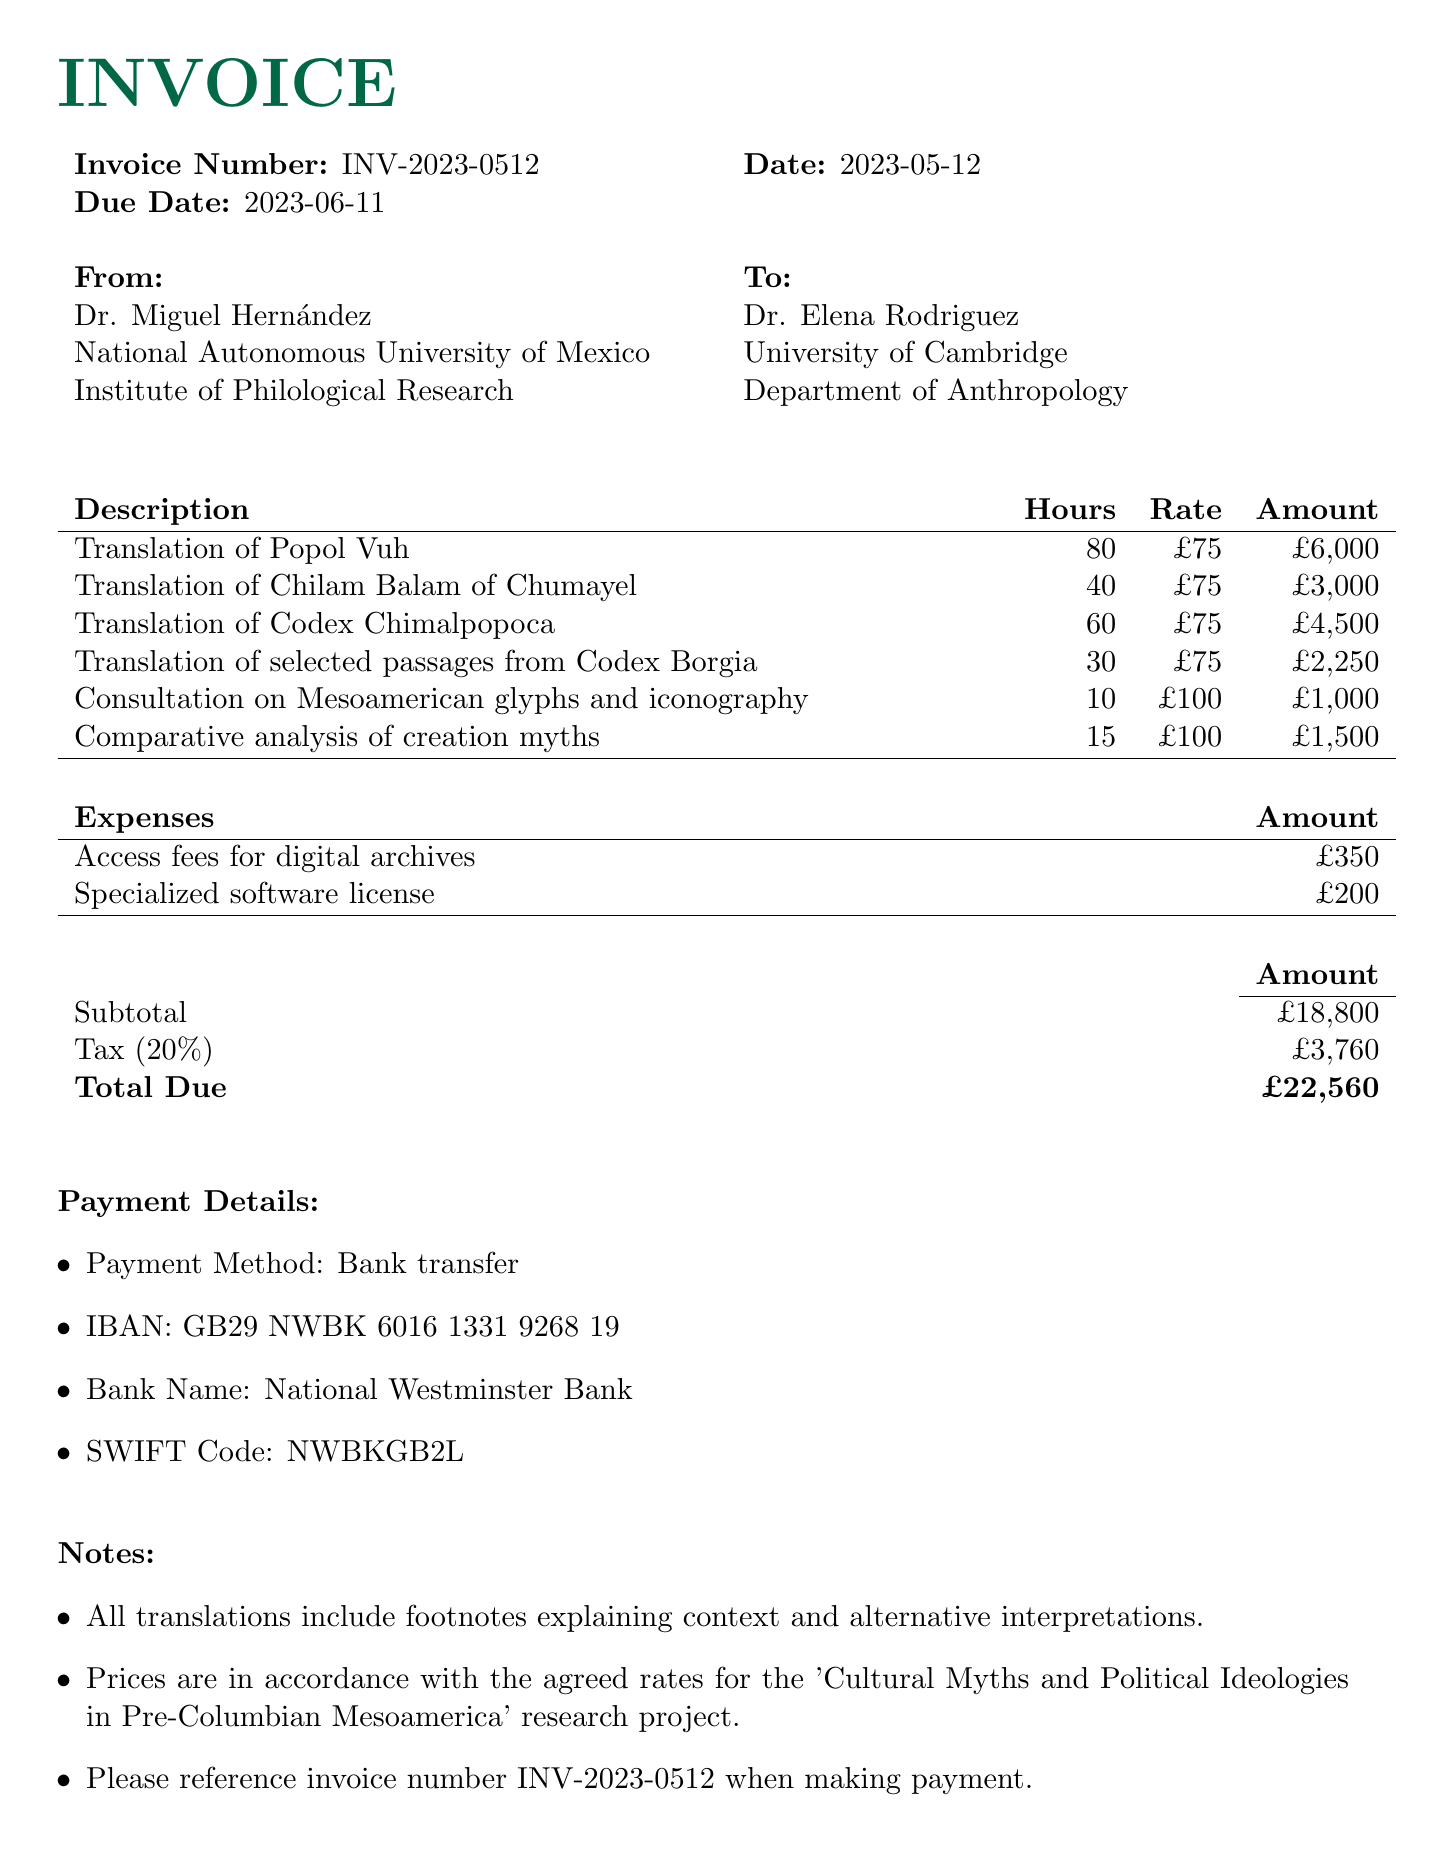What is the invoice number? The invoice number is clearly stated in the document as INV-2023-0512.
Answer: INV-2023-0512 Who is the researcher? The researcher’s name is provided in the invoice details, which is Dr. Elena Rodriguez.
Answer: Dr. Elena Rodriguez What is the due date? The due date for the invoice is mentioned directly in the document, which is 2023-06-11.
Answer: 2023-06-11 How much is charged for the Translation of Codex Chimalpopoca? The amount for the Translation of Codex Chimalpopoca is listed in the invoice items, which is £4,500.
Answer: £4,500 What is the total due amount? The total due amount is calculated at the end of the invoice, which is £22,560.
Answer: £22,560 What type of services are included in the invoice? The services provided are categorized under translation services and additional services.
Answer: Translation services and additional services How many hours were billed for the consultation on Mesoamerican glyphs? The hours billed for this specific consultation service are stated in the document as 10 hours.
Answer: 10 hours What is the tax rate applied to the invoice? The tax rate is stated as a percentage in the document, which is 20%.
Answer: 20% Who should be contacted for queries? The document specifies that Dr. Miguel Hernández is the contact person for any queries.
Answer: Dr. Miguel Hernández 